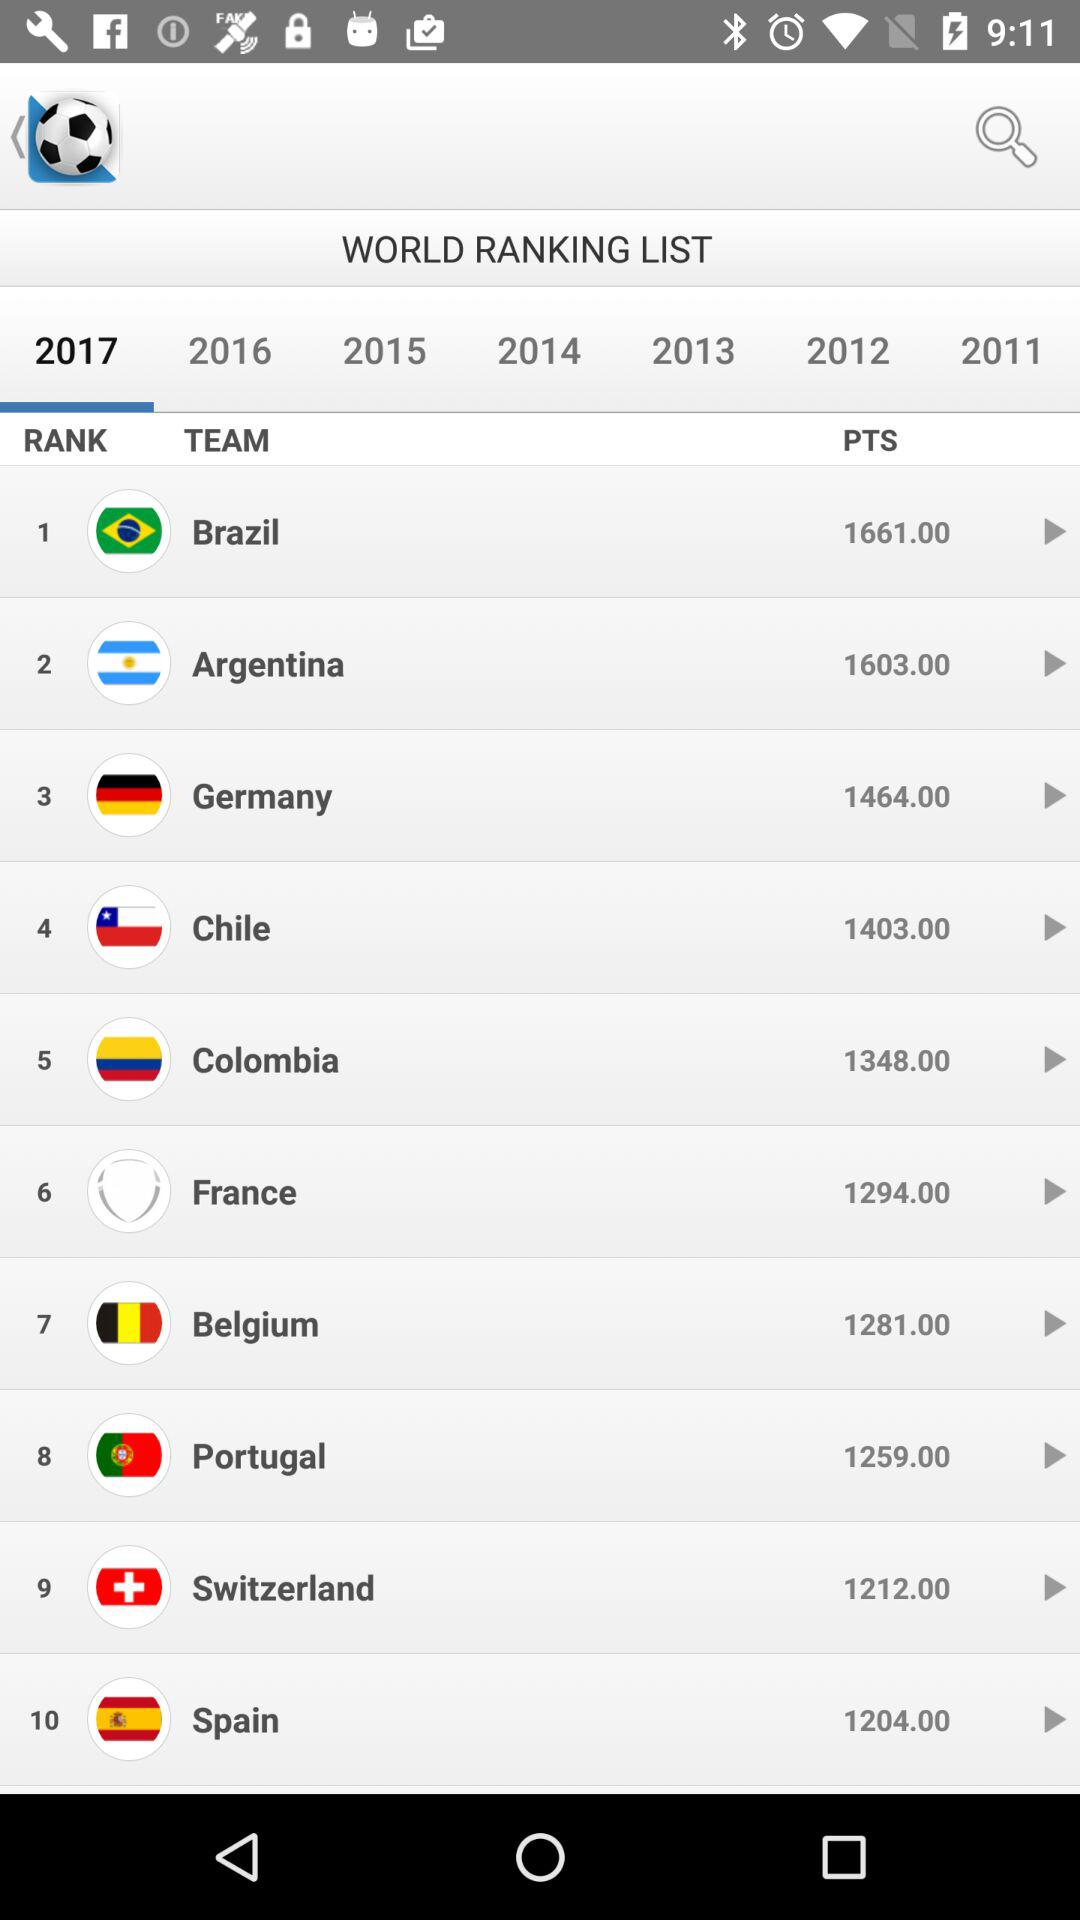What is the point count for "Spain"? The point count is 1204. 